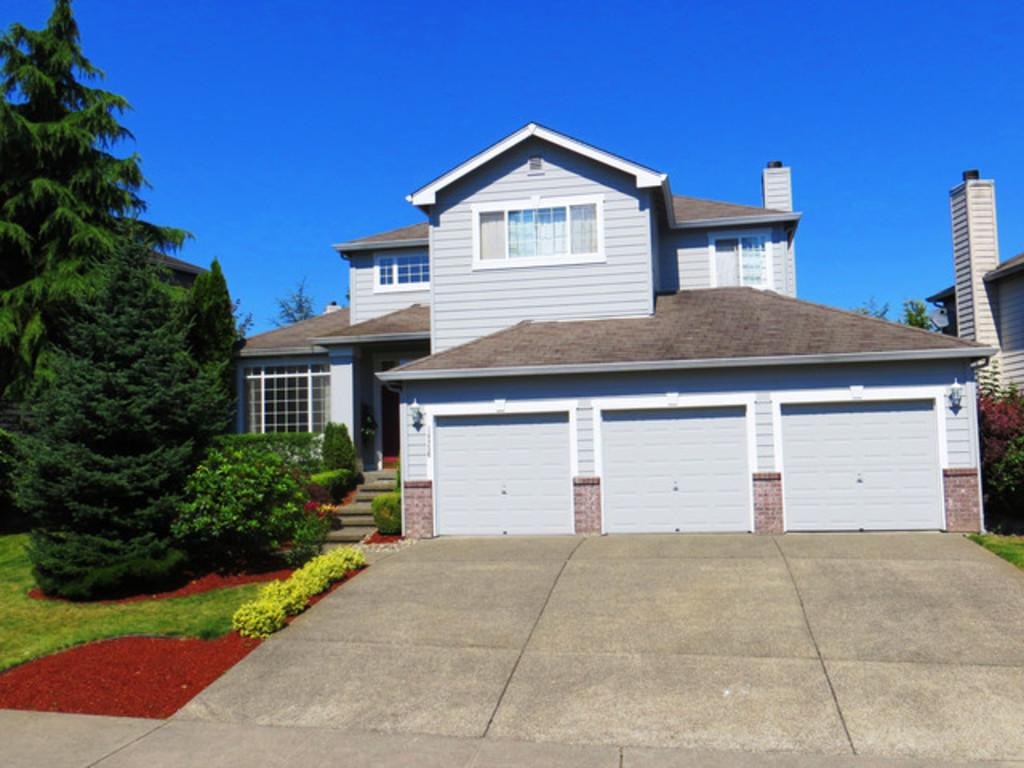What is the main subject in the center of the image? There is a building in the center of the image. How many shutters are on the building? The building has 3 shutters. What type of vegetation is on the left side of the image? There are trees on the left side of the image. What is visible at the top of the image? The sky is visible at the top of the image. Where is the cemetery located in the image? There is no cemetery present in the image. What type of vest is the building wearing in the image? Buildings do not wear vests; the question is not applicable to the image. 